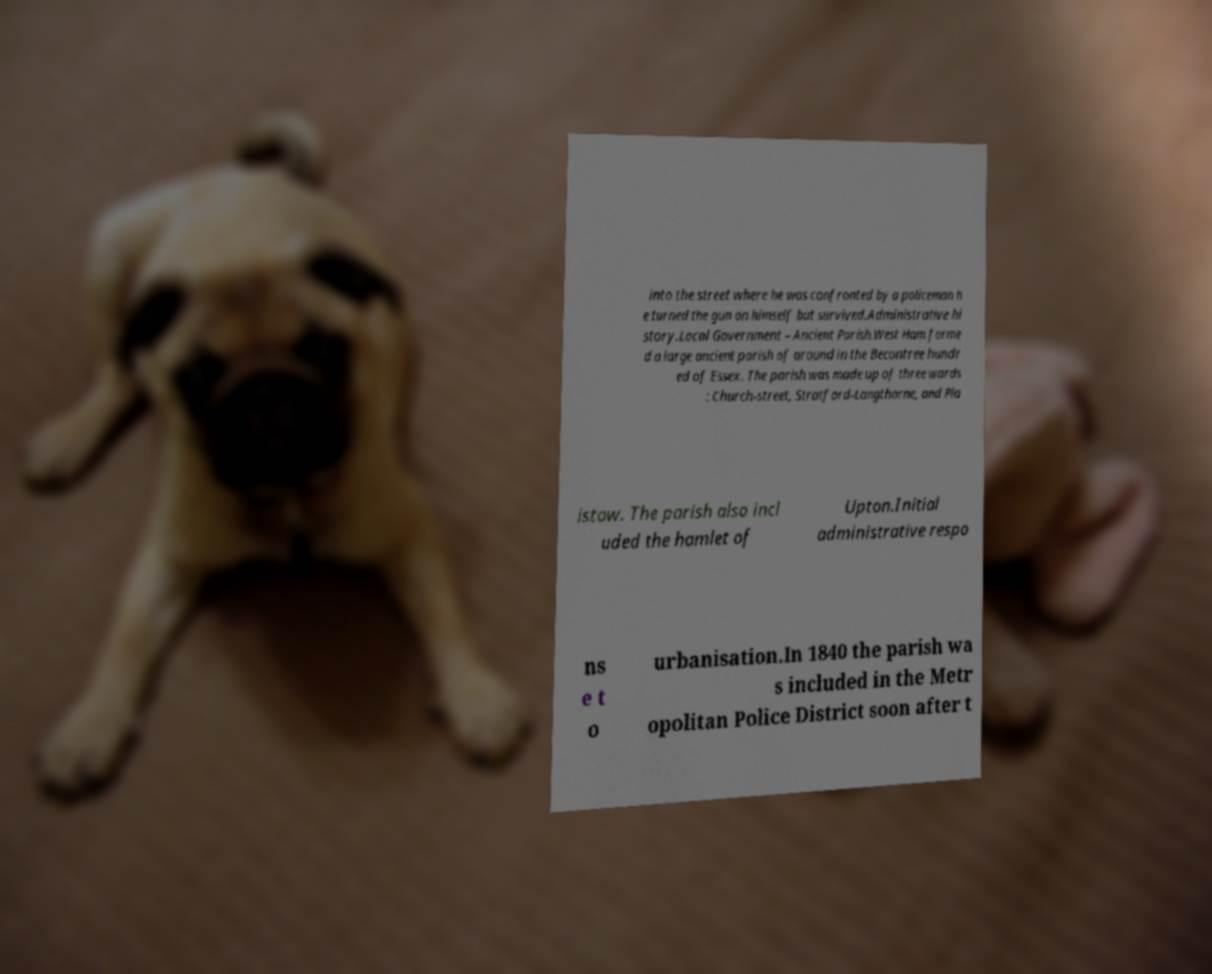What messages or text are displayed in this image? I need them in a readable, typed format. into the street where he was confronted by a policeman h e turned the gun on himself but survived.Administrative hi story.Local Government – Ancient Parish.West Ham forme d a large ancient parish of around in the Becontree hundr ed of Essex. The parish was made up of three wards : Church-street, Stratford-Langthorne, and Pla istow. The parish also incl uded the hamlet of Upton.Initial administrative respo ns e t o urbanisation.In 1840 the parish wa s included in the Metr opolitan Police District soon after t 